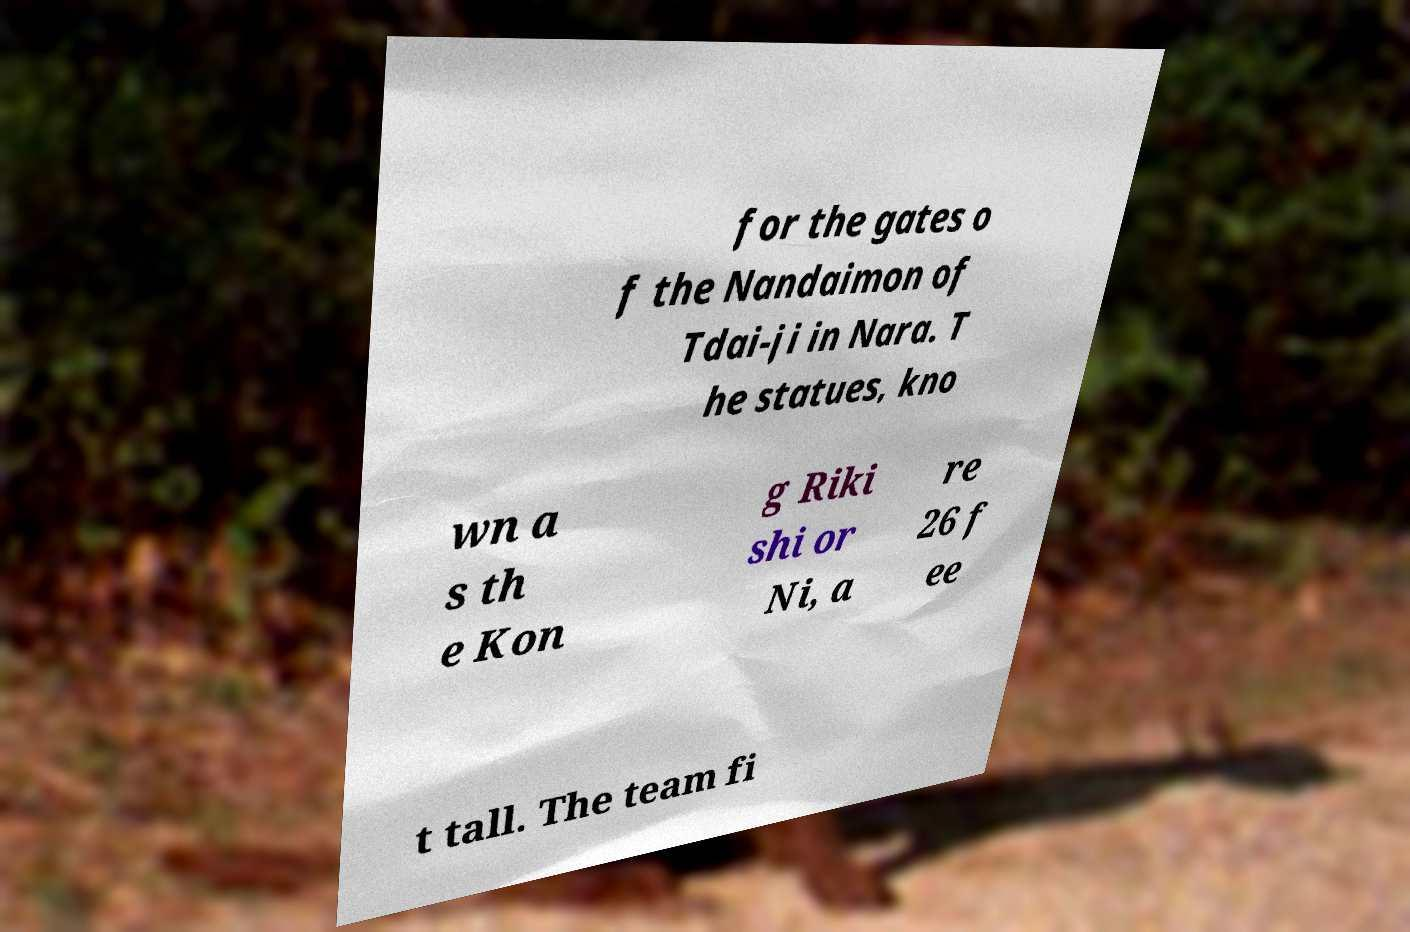Please read and relay the text visible in this image. What does it say? for the gates o f the Nandaimon of Tdai-ji in Nara. T he statues, kno wn a s th e Kon g Riki shi or Ni, a re 26 f ee t tall. The team fi 